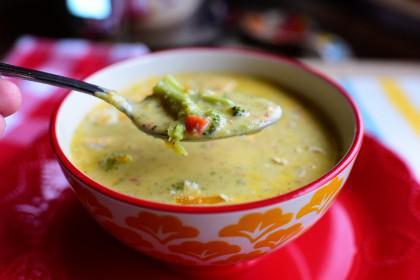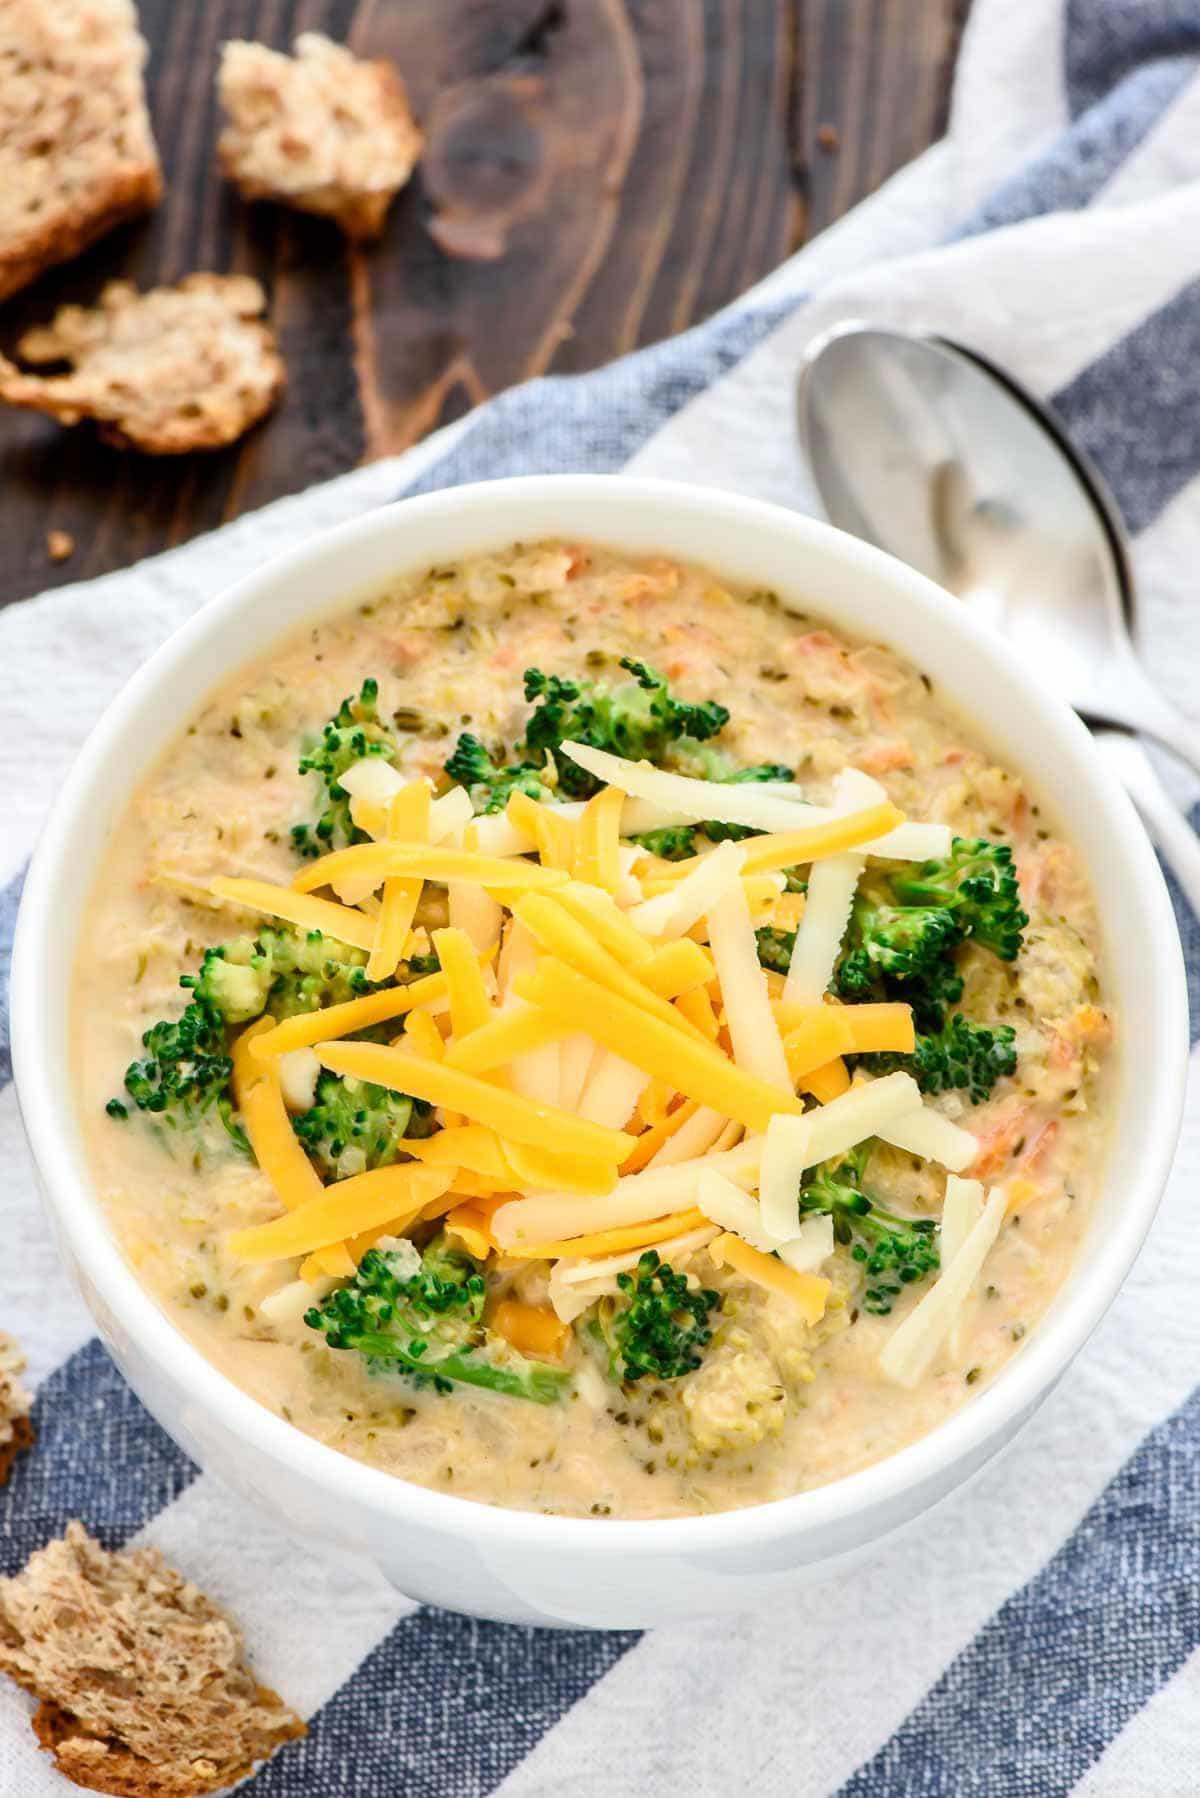The first image is the image on the left, the second image is the image on the right. Assess this claim about the two images: "At least one bowl of soup is garnished with cheese.". Correct or not? Answer yes or no. Yes. The first image is the image on the left, the second image is the image on the right. Considering the images on both sides, is "The bwol of the spoon is visible in the image on the left" valid? Answer yes or no. Yes. 